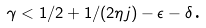<formula> <loc_0><loc_0><loc_500><loc_500>\gamma < 1 / 2 + 1 / ( 2 \eta j ) - \epsilon - \delta \text {.}</formula> 